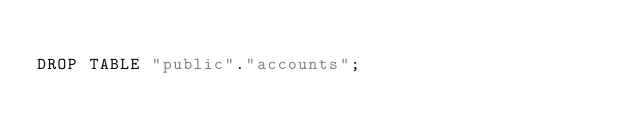Convert code to text. <code><loc_0><loc_0><loc_500><loc_500><_SQL_>
DROP TABLE "public"."accounts";</code> 